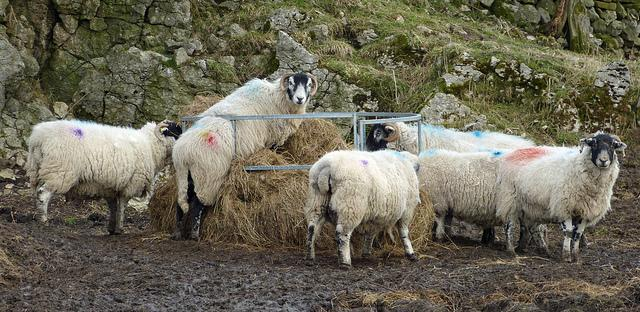What are all of the sheep gathering around in their field? hay 